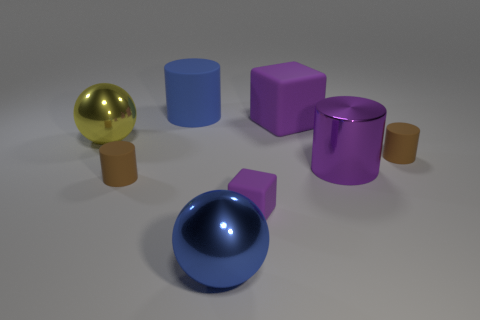Add 1 tiny metallic things. How many objects exist? 9 Subtract all blocks. How many objects are left? 6 Subtract all rubber objects. Subtract all large gray balls. How many objects are left? 3 Add 5 big blue balls. How many big blue balls are left? 6 Add 2 purple matte blocks. How many purple matte blocks exist? 4 Subtract 0 brown cubes. How many objects are left? 8 